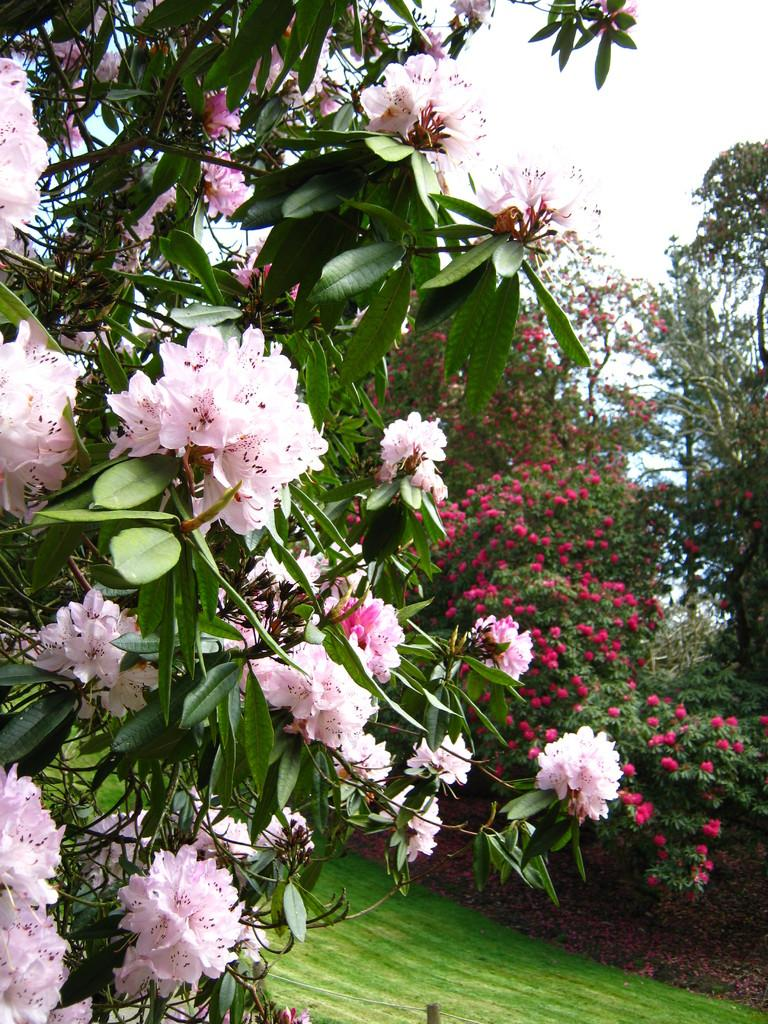What type of flowers can be seen in the image? There are pink color flowers in the image. What else is present along with the flowers? There are leaves in the image. Where are the flowers and leaves located in the image? The flowers and leaves are in the front of the image. What can be seen in the background of the image? There is grass ground and trees visible in the background of the image. How many fish can be seen swimming in the image? There are no fish present in the image. What type of balls are being used by the beginner in the image? There is no beginner or balls present in the image. 